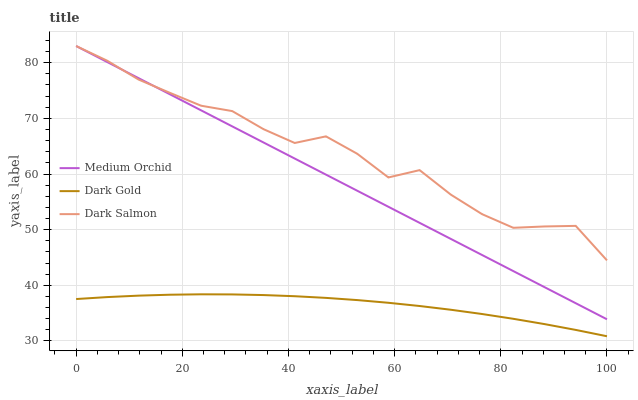Does Dark Gold have the minimum area under the curve?
Answer yes or no. Yes. Does Dark Salmon have the maximum area under the curve?
Answer yes or no. Yes. Does Dark Salmon have the minimum area under the curve?
Answer yes or no. No. Does Dark Gold have the maximum area under the curve?
Answer yes or no. No. Is Medium Orchid the smoothest?
Answer yes or no. Yes. Is Dark Salmon the roughest?
Answer yes or no. Yes. Is Dark Gold the smoothest?
Answer yes or no. No. Is Dark Gold the roughest?
Answer yes or no. No. Does Dark Gold have the lowest value?
Answer yes or no. Yes. Does Dark Salmon have the lowest value?
Answer yes or no. No. Does Dark Salmon have the highest value?
Answer yes or no. Yes. Does Dark Gold have the highest value?
Answer yes or no. No. Is Dark Gold less than Medium Orchid?
Answer yes or no. Yes. Is Dark Salmon greater than Dark Gold?
Answer yes or no. Yes. Does Dark Salmon intersect Medium Orchid?
Answer yes or no. Yes. Is Dark Salmon less than Medium Orchid?
Answer yes or no. No. Is Dark Salmon greater than Medium Orchid?
Answer yes or no. No. Does Dark Gold intersect Medium Orchid?
Answer yes or no. No. 